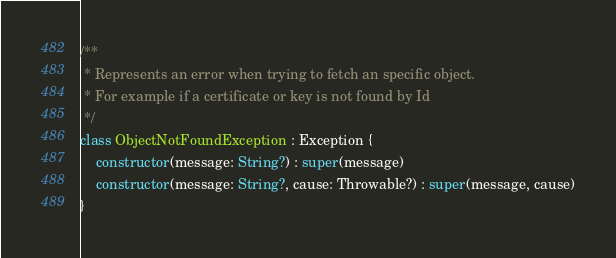<code> <loc_0><loc_0><loc_500><loc_500><_Kotlin_>/**
 * Represents an error when trying to fetch an specific object.
 * For example if a certificate or key is not found by Id
 */
class ObjectNotFoundException : Exception {
    constructor(message: String?) : super(message)
    constructor(message: String?, cause: Throwable?) : super(message, cause)
}

</code> 